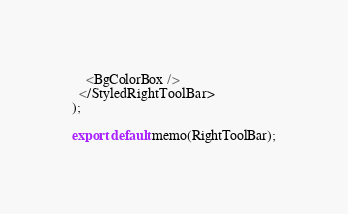<code> <loc_0><loc_0><loc_500><loc_500><_TypeScript_>    <BgColorBox />
  </StyledRightToolBar>
);

export default memo(RightToolBar);
</code> 